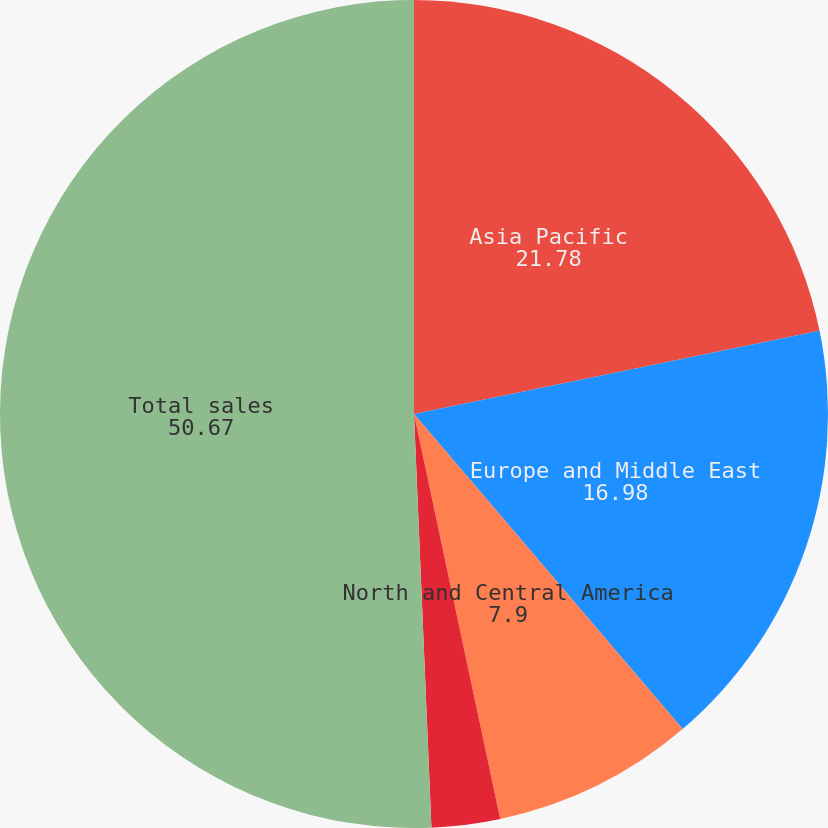Convert chart. <chart><loc_0><loc_0><loc_500><loc_500><pie_chart><fcel>Asia Pacific<fcel>Europe and Middle East<fcel>North and Central America<fcel>Africa<fcel>Total sales<nl><fcel>21.78%<fcel>16.98%<fcel>7.9%<fcel>2.67%<fcel>50.67%<nl></chart> 